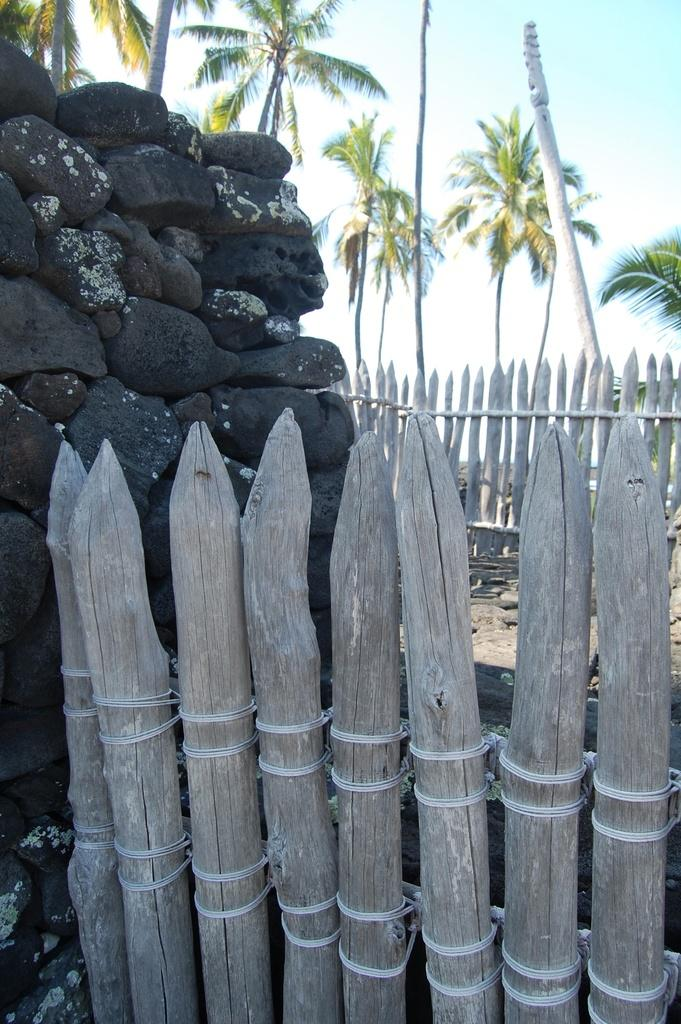What type of fencing is present in the image? There is wooden fencing in the image. What other structure can be seen in the image? There is a stone wall in the image. What can be seen under the fencing and wall? The ground is visible in the image. What is visible in the background of the image? There are trees, a pole, and the sky visible in the background of the image. Who is the friend that can be seen standing next to the pole in the image? There is no person, including a friend, present in the image. 